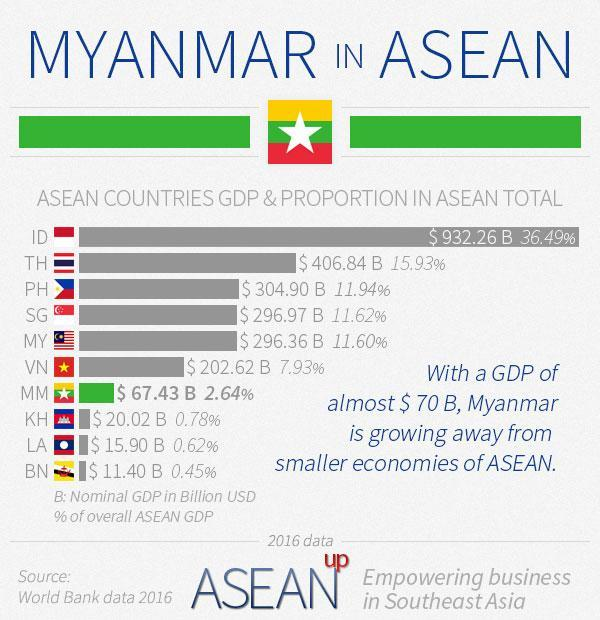Which are the countries which contribute more than 10% and less than 15% in GDP to ASEAN TOTAL
Answer the question with a short phrase. PH, SG, MY Which country's bar chart is in Green MM, Myanmar Which countries contribute less than 1% GDP each KH, LA, BN 